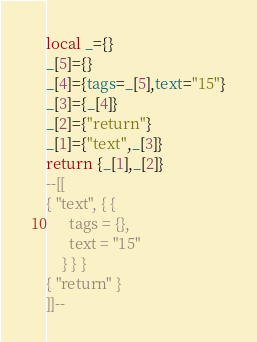<code> <loc_0><loc_0><loc_500><loc_500><_Lua_>local _={}
_[5]={}
_[4]={tags=_[5],text="15"}
_[3]={_[4]}
_[2]={"return"}
_[1]={"text",_[3]}
return {_[1],_[2]}
--[[
{ "text", { {
      tags = {},
      text = "15"
    } } }
{ "return" }
]]--</code> 